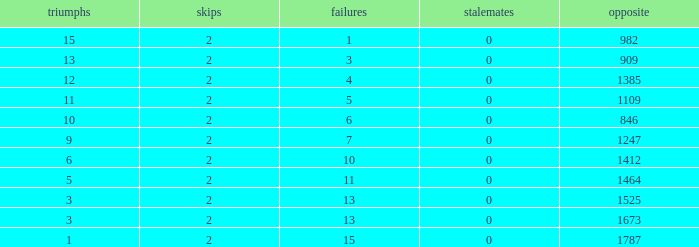What is the average number of Byes when there were less than 0 losses and were against 1247? None. 